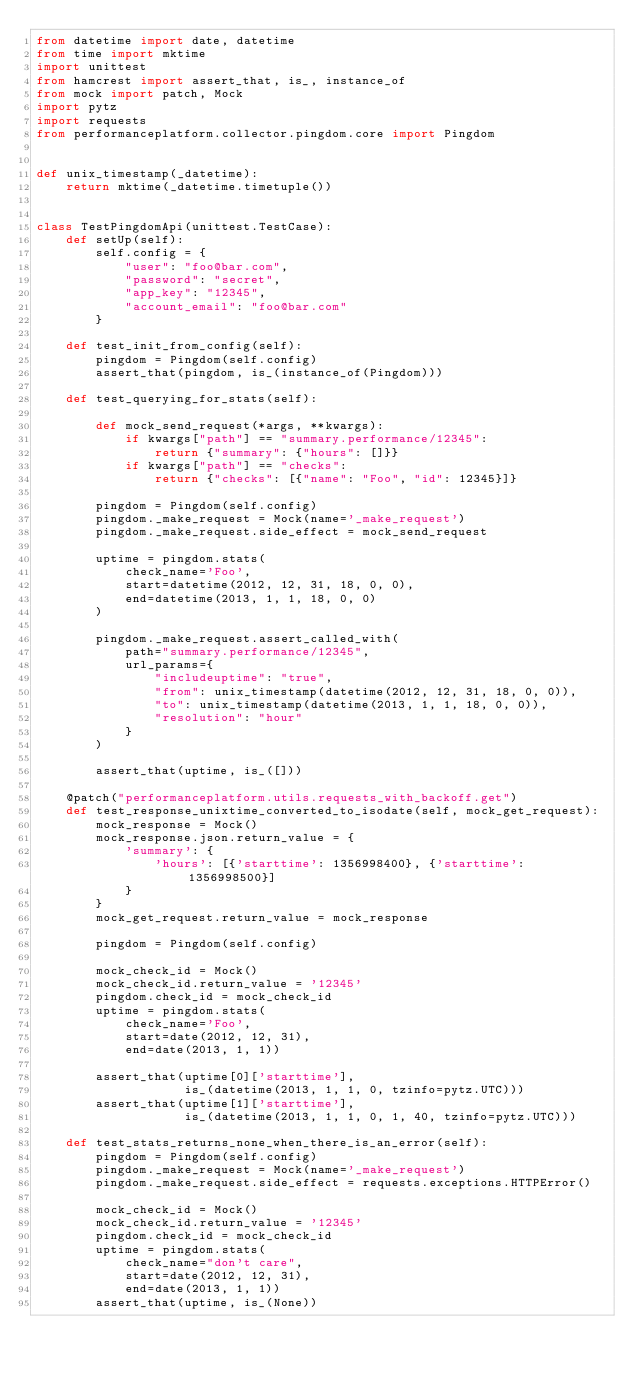<code> <loc_0><loc_0><loc_500><loc_500><_Python_>from datetime import date, datetime
from time import mktime
import unittest
from hamcrest import assert_that, is_, instance_of
from mock import patch, Mock
import pytz
import requests
from performanceplatform.collector.pingdom.core import Pingdom


def unix_timestamp(_datetime):
    return mktime(_datetime.timetuple())


class TestPingdomApi(unittest.TestCase):
    def setUp(self):
        self.config = {
            "user": "foo@bar.com",
            "password": "secret",
            "app_key": "12345",
            "account_email": "foo@bar.com"
        }

    def test_init_from_config(self):
        pingdom = Pingdom(self.config)
        assert_that(pingdom, is_(instance_of(Pingdom)))

    def test_querying_for_stats(self):

        def mock_send_request(*args, **kwargs):
            if kwargs["path"] == "summary.performance/12345":
                return {"summary": {"hours": []}}
            if kwargs["path"] == "checks":
                return {"checks": [{"name": "Foo", "id": 12345}]}

        pingdom = Pingdom(self.config)
        pingdom._make_request = Mock(name='_make_request')
        pingdom._make_request.side_effect = mock_send_request

        uptime = pingdom.stats(
            check_name='Foo',
            start=datetime(2012, 12, 31, 18, 0, 0),
            end=datetime(2013, 1, 1, 18, 0, 0)
        )

        pingdom._make_request.assert_called_with(
            path="summary.performance/12345",
            url_params={
                "includeuptime": "true",
                "from": unix_timestamp(datetime(2012, 12, 31, 18, 0, 0)),
                "to": unix_timestamp(datetime(2013, 1, 1, 18, 0, 0)),
                "resolution": "hour"
            }
        )

        assert_that(uptime, is_([]))

    @patch("performanceplatform.utils.requests_with_backoff.get")
    def test_response_unixtime_converted_to_isodate(self, mock_get_request):
        mock_response = Mock()
        mock_response.json.return_value = {
            'summary': {
                'hours': [{'starttime': 1356998400}, {'starttime': 1356998500}]
            }
        }
        mock_get_request.return_value = mock_response

        pingdom = Pingdom(self.config)

        mock_check_id = Mock()
        mock_check_id.return_value = '12345'
        pingdom.check_id = mock_check_id
        uptime = pingdom.stats(
            check_name='Foo',
            start=date(2012, 12, 31),
            end=date(2013, 1, 1))

        assert_that(uptime[0]['starttime'],
                    is_(datetime(2013, 1, 1, 0, tzinfo=pytz.UTC)))
        assert_that(uptime[1]['starttime'],
                    is_(datetime(2013, 1, 1, 0, 1, 40, tzinfo=pytz.UTC)))

    def test_stats_returns_none_when_there_is_an_error(self):
        pingdom = Pingdom(self.config)
        pingdom._make_request = Mock(name='_make_request')
        pingdom._make_request.side_effect = requests.exceptions.HTTPError()

        mock_check_id = Mock()
        mock_check_id.return_value = '12345'
        pingdom.check_id = mock_check_id
        uptime = pingdom.stats(
            check_name="don't care",
            start=date(2012, 12, 31),
            end=date(2013, 1, 1))
        assert_that(uptime, is_(None))
</code> 